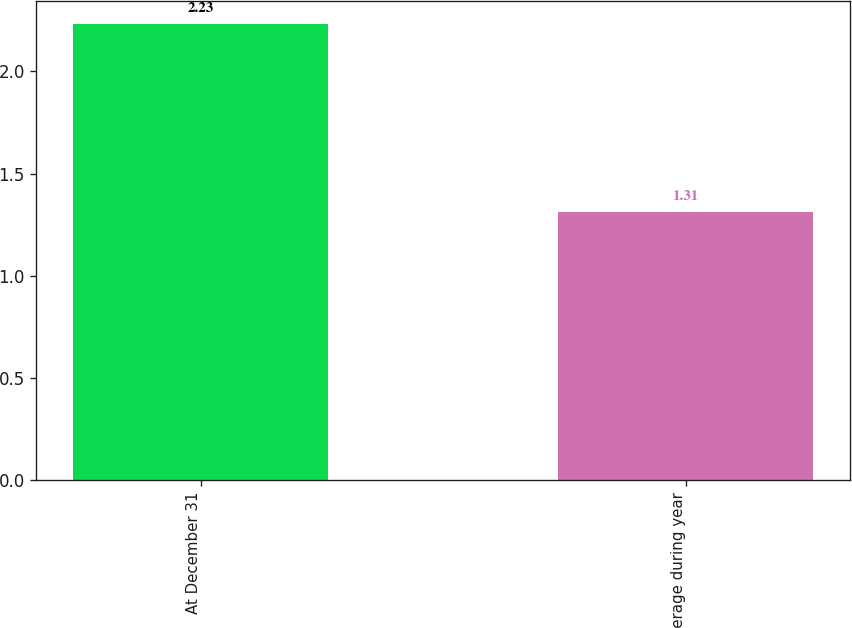Convert chart to OTSL. <chart><loc_0><loc_0><loc_500><loc_500><bar_chart><fcel>At December 31<fcel>Average during year<nl><fcel>2.23<fcel>1.31<nl></chart> 